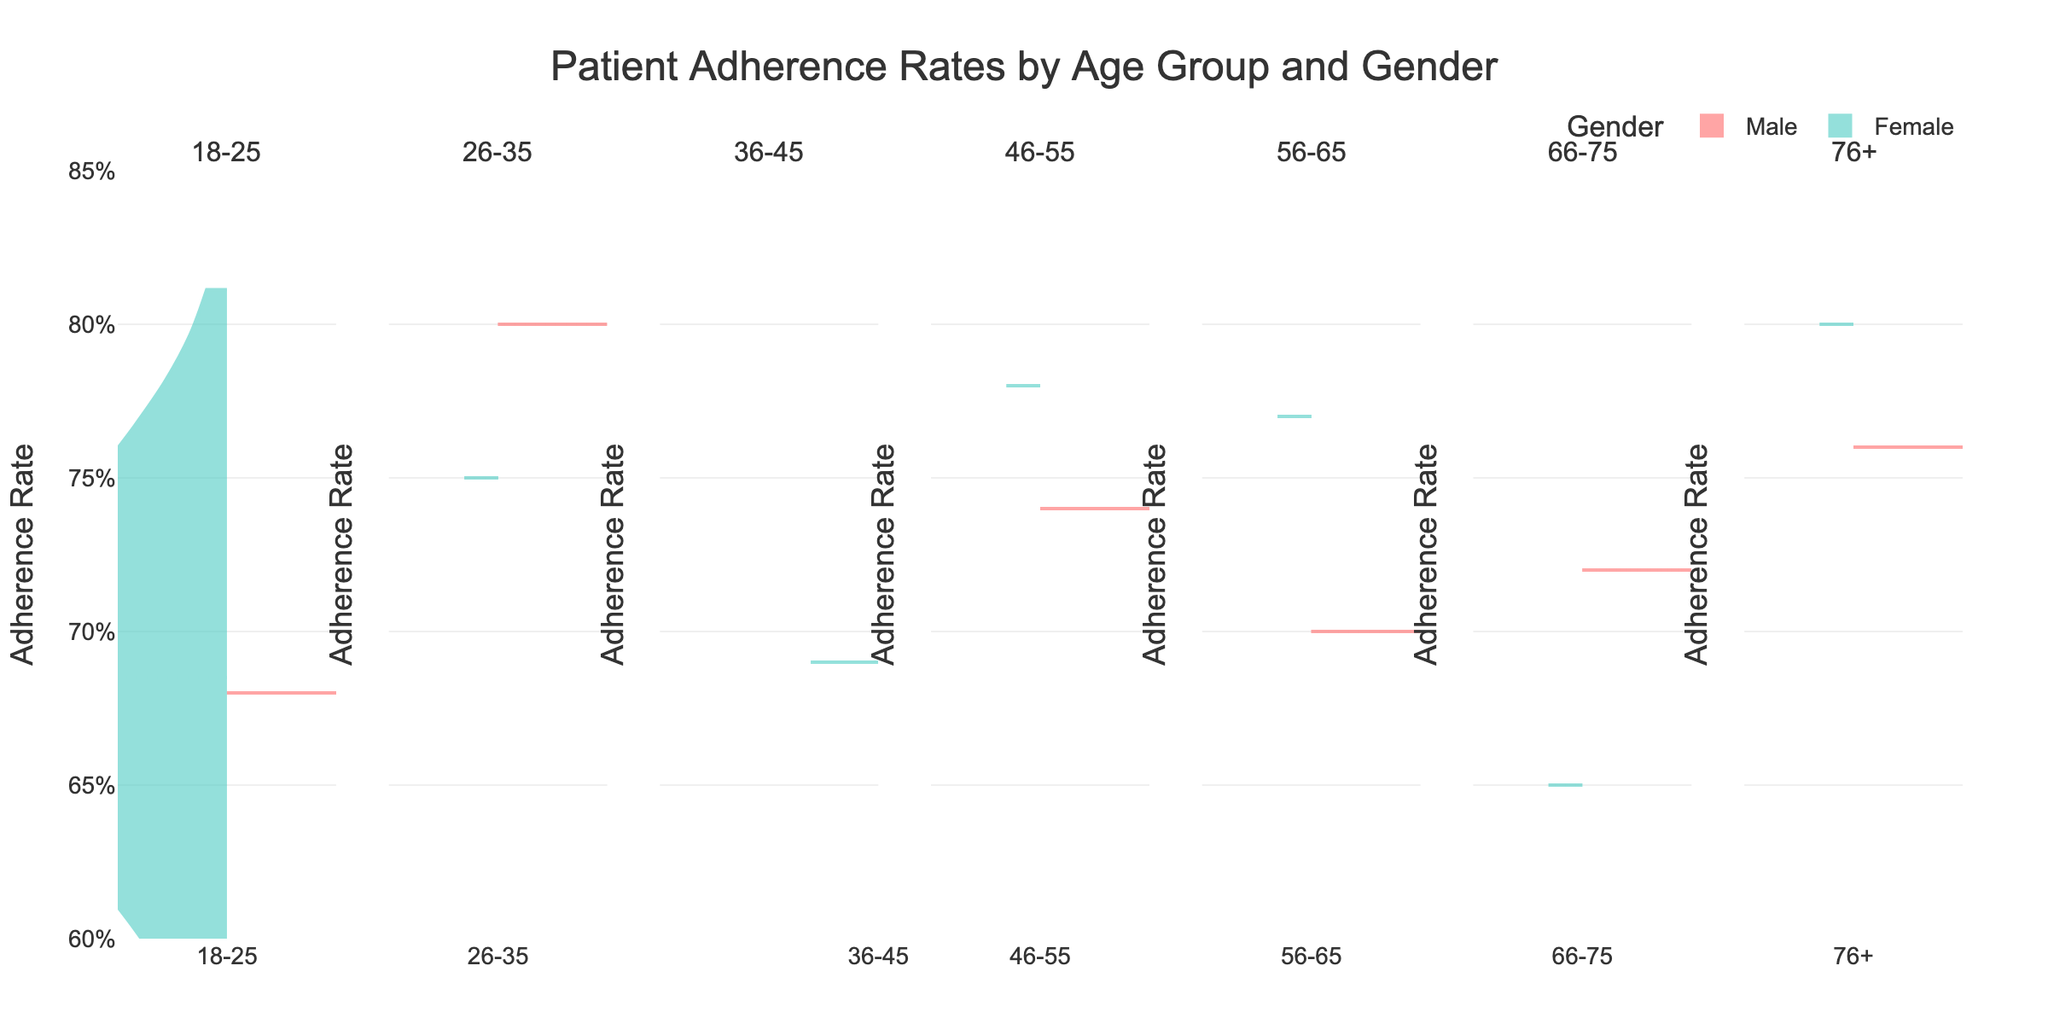How are patient adherence rates segmented in the chart? The patient adherence rates are segmented by age group and gender. Each segment shows adherence rates for different age groups, and within each age group, adherence rates for males and females are displayed on opposite sides of the violin plots.
Answer: By age group and gender Which age group has the highest adherence rate? The age group 76+ has the highest adherence rate for females (0.80) and a comparatively high rate for males as well (0.76).
Answer: 76+ Is there a noticeable difference in adherence rates between genders in any age group? Yes, in the 66-75 age group, females have a higher adherence rate (0.65) compared to males (0.72).
Answer: Yes What can you infer about the adherence rates among males across different age groups? Males in the 26-35 and 76+ age groups exhibit the highest adherence rates (0.80 and 0.76 respectively), while those in the 18-25 and 46-55 age groups show slightly lower adherence rates.
Answer: Highest in 26-35 and 76+ How does the adherence rate of females compare to males in the 56-65 age group? In the 56-65 age group, females have a higher adherence rate (0.77) compared to males (0.70). This shows that females are generally more adherent to prescribed medication regimens in this age group.
Answer: Females have higher adherence Which age group shows the smallest difference in adherence rates between genders? The 66-75 age group shows a small difference in adherence rates between genders, particularly with males having 0.72 and females having 0.65, unlike other age groups with larger discrepancies.
Answer: 66-75 What does the mean line visible in the violin plots represent? The mean line in each violin plot represents the average adherence rate for that specific gender and age group, providing a visual indicator of the central tendency.
Answer: Average adherence rate Are there any age groups where females have lower adherence rates than males? Yes, in the 66-75 age group, females have a lower adherence rate (0.65) compared to males (0.72).
Answer: Yes How do the adherence rates for females aged 46-55 compare to those aged 76+? Females aged 76+ have a higher adherence rate (0.80) compared to females aged 46-55 (0.78), suggesting an increase in adherence with age among women.
Answer: Higher in 76+ Are adherence rates more variable for any gender within specific age groups? The adherence rates for males tend to show more variability within each age group compared to females, especially in the 46-55 and 66-75 age groups.
Answer: Yes, for males 